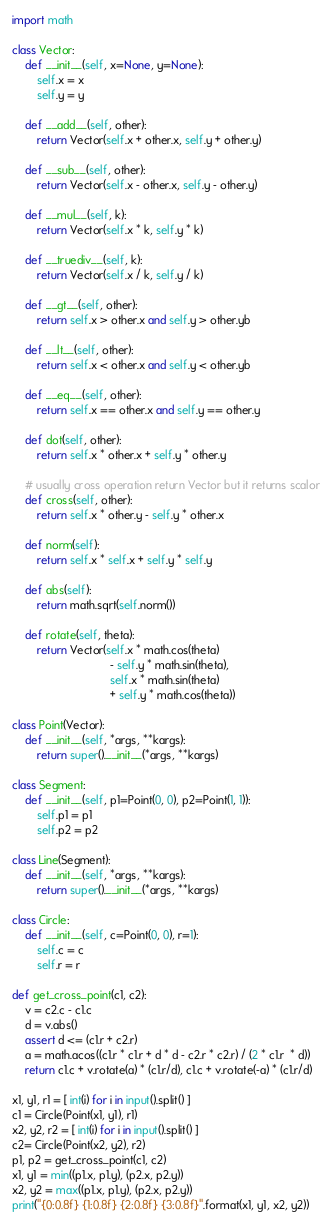<code> <loc_0><loc_0><loc_500><loc_500><_Python_>import math

class Vector:
    def __init__(self, x=None, y=None):
        self.x = x
        self.y = y

    def __add__(self, other):
        return Vector(self.x + other.x, self.y + other.y)

    def __sub__(self, other):
        return Vector(self.x - other.x, self.y - other.y)

    def __mul__(self, k):
        return Vector(self.x * k, self.y * k)

    def __truediv__(self, k):
        return Vector(self.x / k, self.y / k)

    def __gt__(self, other):
        return self.x > other.x and self.y > other.yb

    def __lt__(self, other):
        return self.x < other.x and self.y < other.yb

    def __eq__(self, other):
        return self.x == other.x and self.y == other.y

    def dot(self, other):
        return self.x * other.x + self.y * other.y

    # usually cross operation return Vector but it returns scalor
    def cross(self, other):
        return self.x * other.y - self.y * other.x

    def norm(self):
        return self.x * self.x + self.y * self.y

    def abs(self):
        return math.sqrt(self.norm())

    def rotate(self, theta):
        return Vector(self.x * math.cos(theta)
                               - self.y * math.sin(theta),
                               self.x * math.sin(theta)
                               + self.y * math.cos(theta))

class Point(Vector):
    def __init__(self, *args, **kargs):
        return super().__init__(*args, **kargs)

class Segment:
    def __init__(self, p1=Point(0, 0), p2=Point(1, 1)):
        self.p1 = p1
        self.p2 = p2

class Line(Segment):
    def __init__(self, *args, **kargs):
        return super().__init__(*args, **kargs)

class Circle:
    def __init__(self, c=Point(0, 0), r=1):
        self.c = c
        self.r = r

def get_cross_point(c1, c2):
    v = c2.c - c1.c
    d = v.abs()
    assert d <= (c1.r + c2.r)
    a = math.acos((c1.r * c1.r + d * d - c2.r * c2.r) / (2 * c1.r  * d))
    return c1.c + v.rotate(a) * (c1.r/d), c1.c + v.rotate(-a) * (c1.r/d)

x1, y1, r1 = [ int(i) for i in input().split() ]
c1 = Circle(Point(x1, y1), r1)
x2, y2, r2 = [ int(i) for i in input().split() ]
c2= Circle(Point(x2, y2), r2)
p1, p2 = get_cross_point(c1, c2)
x1, y1 = min((p1.x, p1.y), (p2.x, p2.y))
x2, y2 = max((p1.x, p1.y), (p2.x, p2.y))
print("{0:0.8f} {1:0.8f} {2:0.8f} {3:0.8f}".format(x1, y1, x2, y2))
</code> 